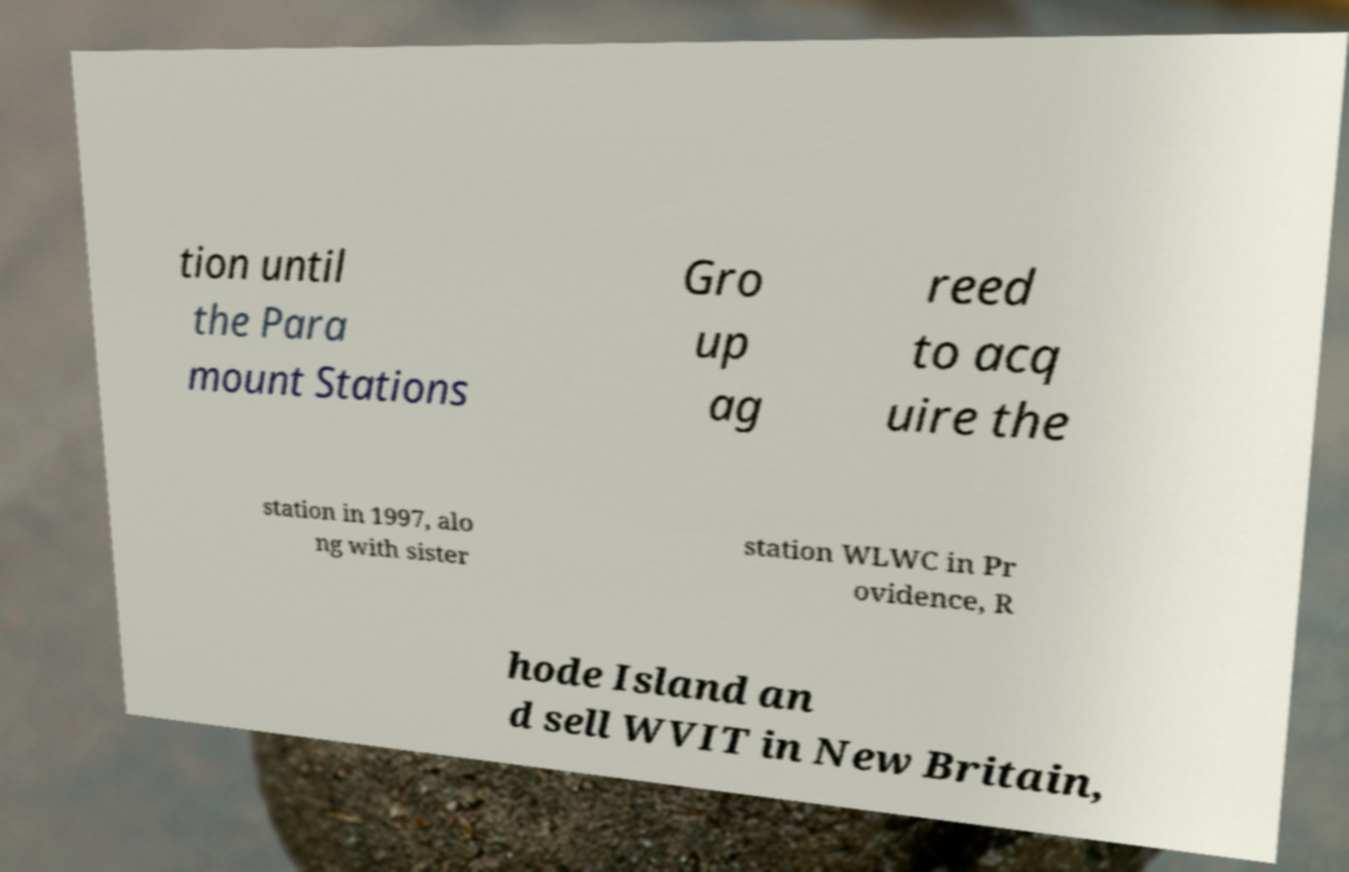Please identify and transcribe the text found in this image. tion until the Para mount Stations Gro up ag reed to acq uire the station in 1997, alo ng with sister station WLWC in Pr ovidence, R hode Island an d sell WVIT in New Britain, 